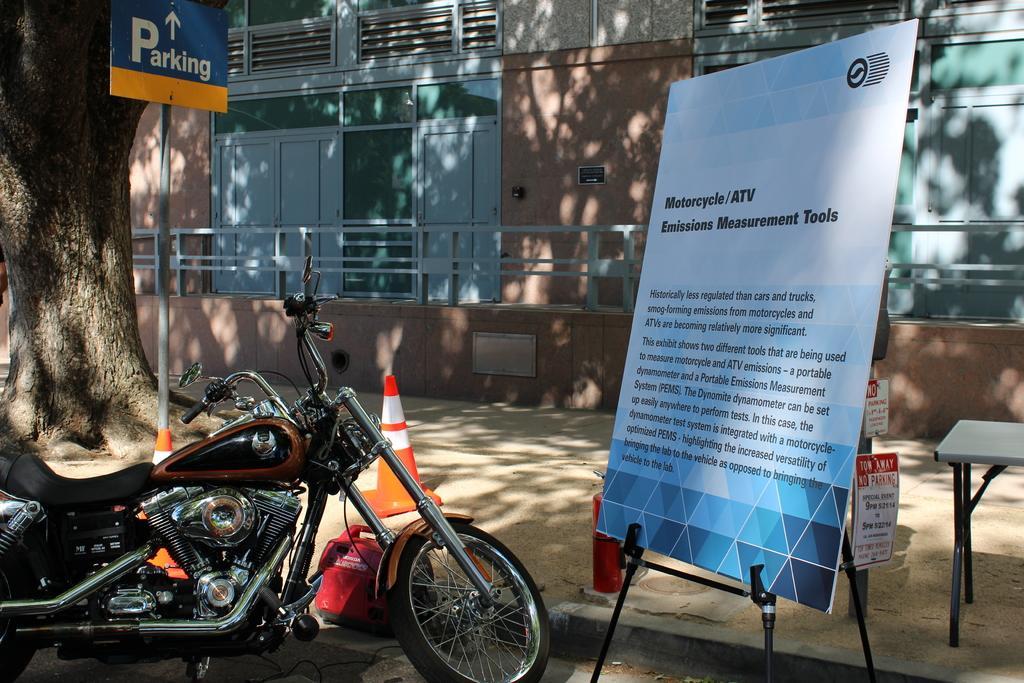How would you summarize this image in a sentence or two? The image is outside of the city. In the image on left side there is a bike, on right side there is a hoarding. In background there is a building,door which are closed and windows and also a tree. 